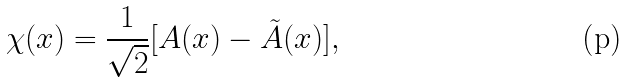Convert formula to latex. <formula><loc_0><loc_0><loc_500><loc_500>\chi ( x ) = \frac { 1 } { \sqrt { 2 } } [ A ( x ) - \tilde { A } ( x ) ] ,</formula> 